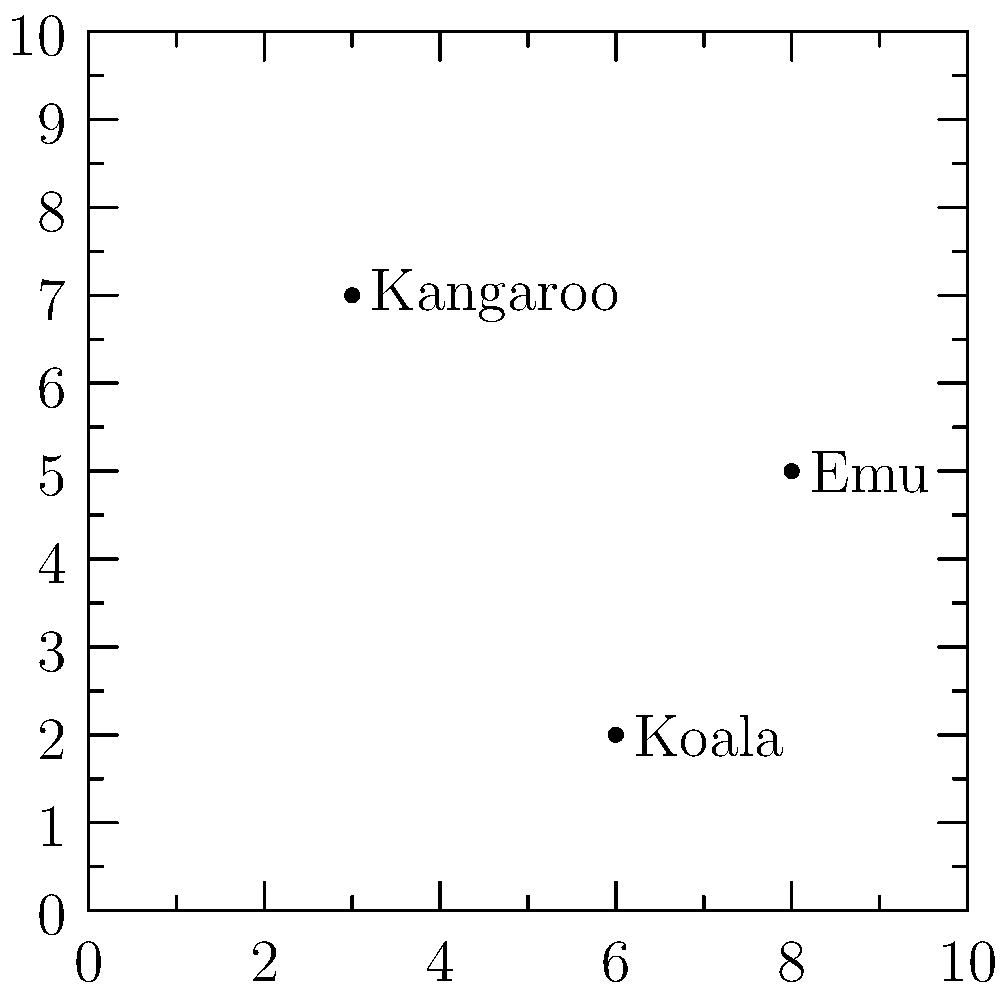On the map grid above, three native Australian animals are plotted. The Kangaroo is located at (3,7), the Koala at (6,2), and the Emu at (8,5). Which animal is located farthest north on the grid? To determine which animal is farthest north on the grid, we need to compare their y-coordinates, as the y-axis represents the north-south direction on most maps. The higher the y-coordinate, the farther north the animal is located.

Let's examine the y-coordinates of each animal:

1. Kangaroo: (3,7) - y-coordinate is 7
2. Koala: (6,2) - y-coordinate is 2
3. Emu: (8,5) - y-coordinate is 5

Comparing these y-coordinates:

7 (Kangaroo) > 5 (Emu) > 2 (Koala)

Therefore, the Kangaroo has the highest y-coordinate and is located farthest north on the grid.
Answer: Kangaroo 